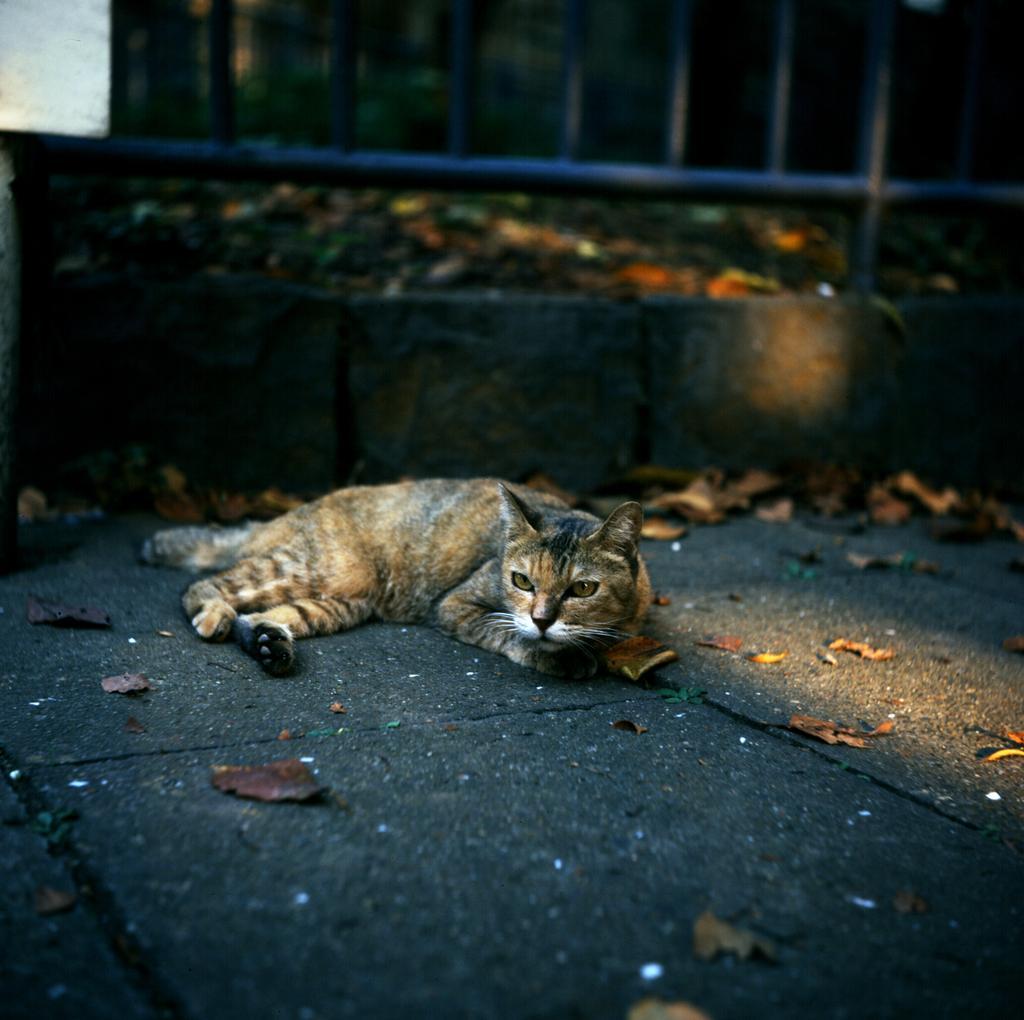How would you summarize this image in a sentence or two? In this image there is a cat on the ground, there are dried leaves on the ground, there is an object truncated towards the top of the image, there is an object truncated towards the right of the image, there are leaves truncated towards the right of the image, there is a leaf truncated towards the bottom of the image. 